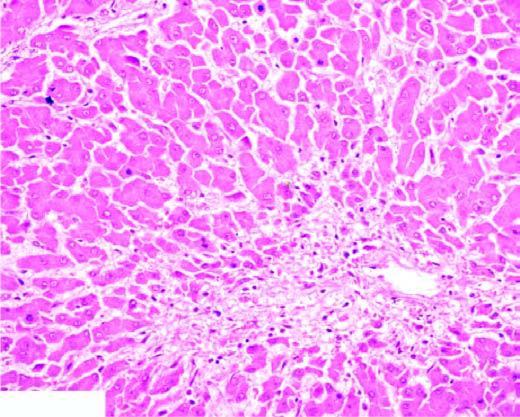what shows mild fatty change of liver cells?
Answer the question using a single word or phrase. The peripheral zone 